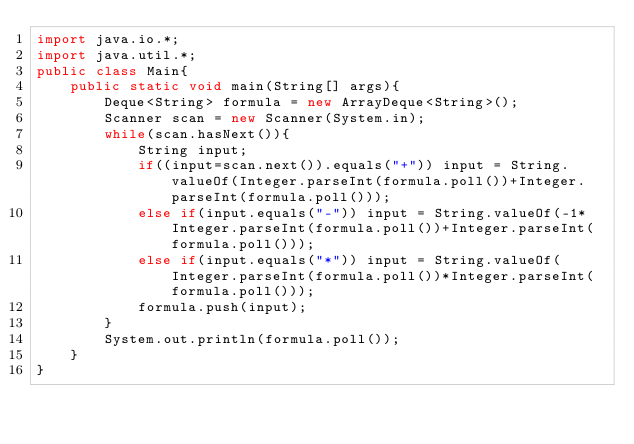<code> <loc_0><loc_0><loc_500><loc_500><_Java_>import java.io.*;
import java.util.*;
public class Main{
    public static void main(String[] args){
        Deque<String> formula = new ArrayDeque<String>();
        Scanner scan = new Scanner(System.in);
        while(scan.hasNext()){
            String input;
            if((input=scan.next()).equals("+")) input = String.valueOf(Integer.parseInt(formula.poll())+Integer.parseInt(formula.poll()));
            else if(input.equals("-")) input = String.valueOf(-1*Integer.parseInt(formula.poll())+Integer.parseInt(formula.poll()));
            else if(input.equals("*")) input = String.valueOf(Integer.parseInt(formula.poll())*Integer.parseInt(formula.poll()));
            formula.push(input);
        }
        System.out.println(formula.poll());
    }
}</code> 